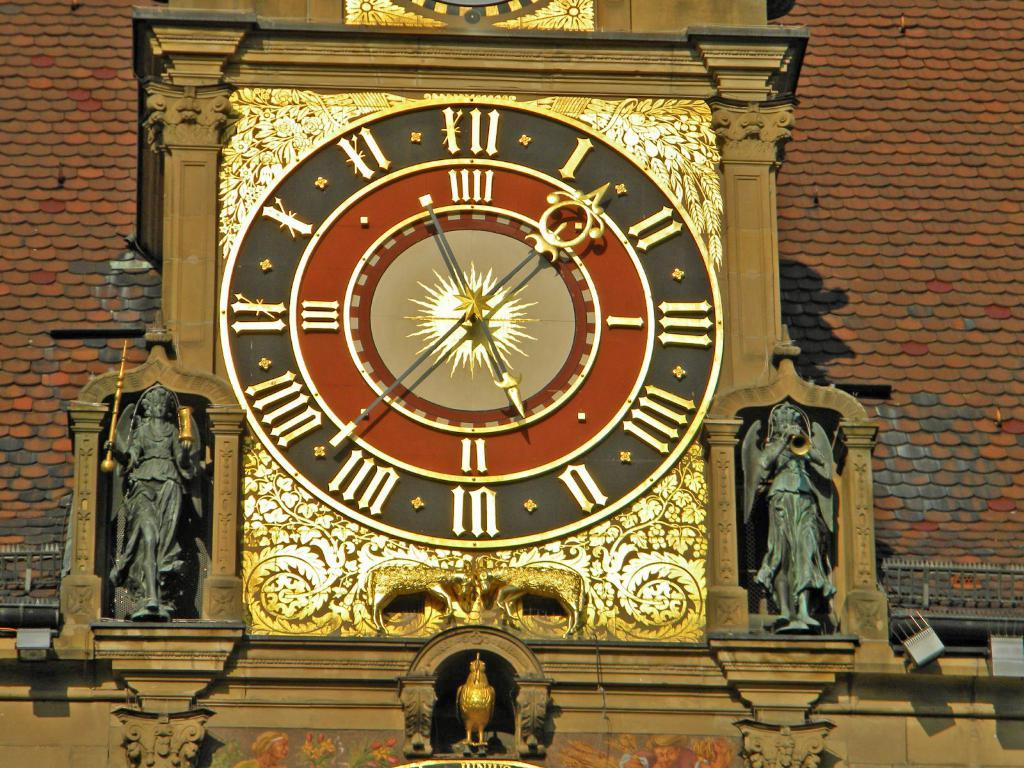<image>
Render a clear and concise summary of the photo. a clock with the roman numeral XII on it 